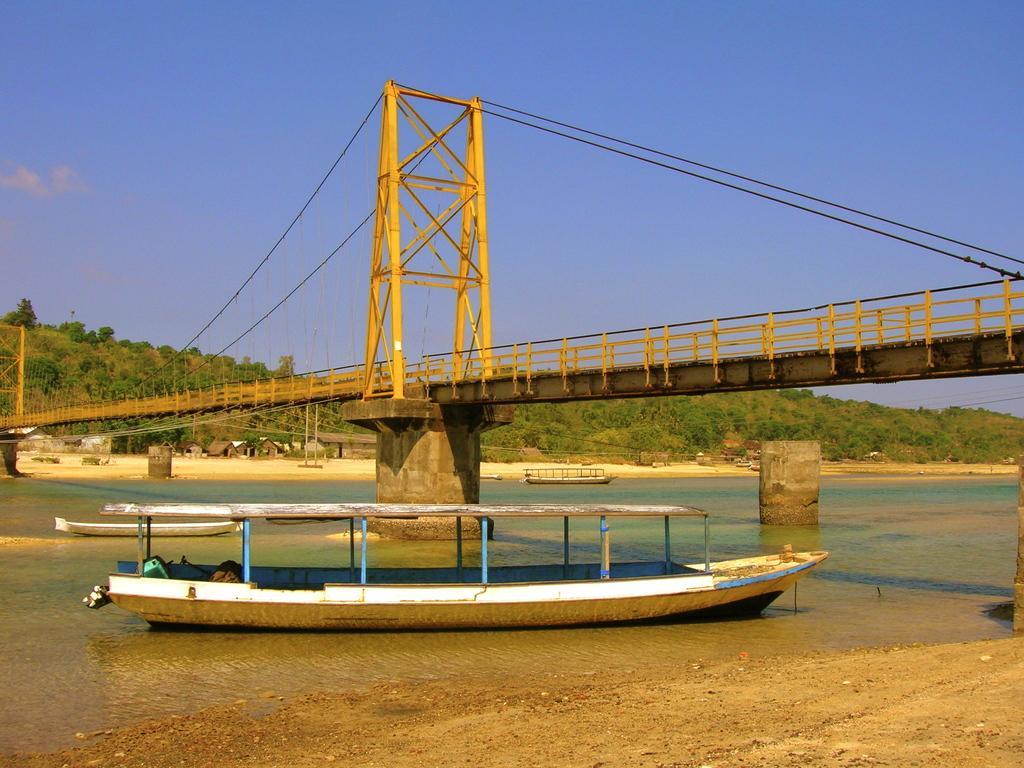Could you give a brief overview of what you see in this image? In this image there is a boat on a river and there a bridge across the river in the background there are trees and a blue sky. 